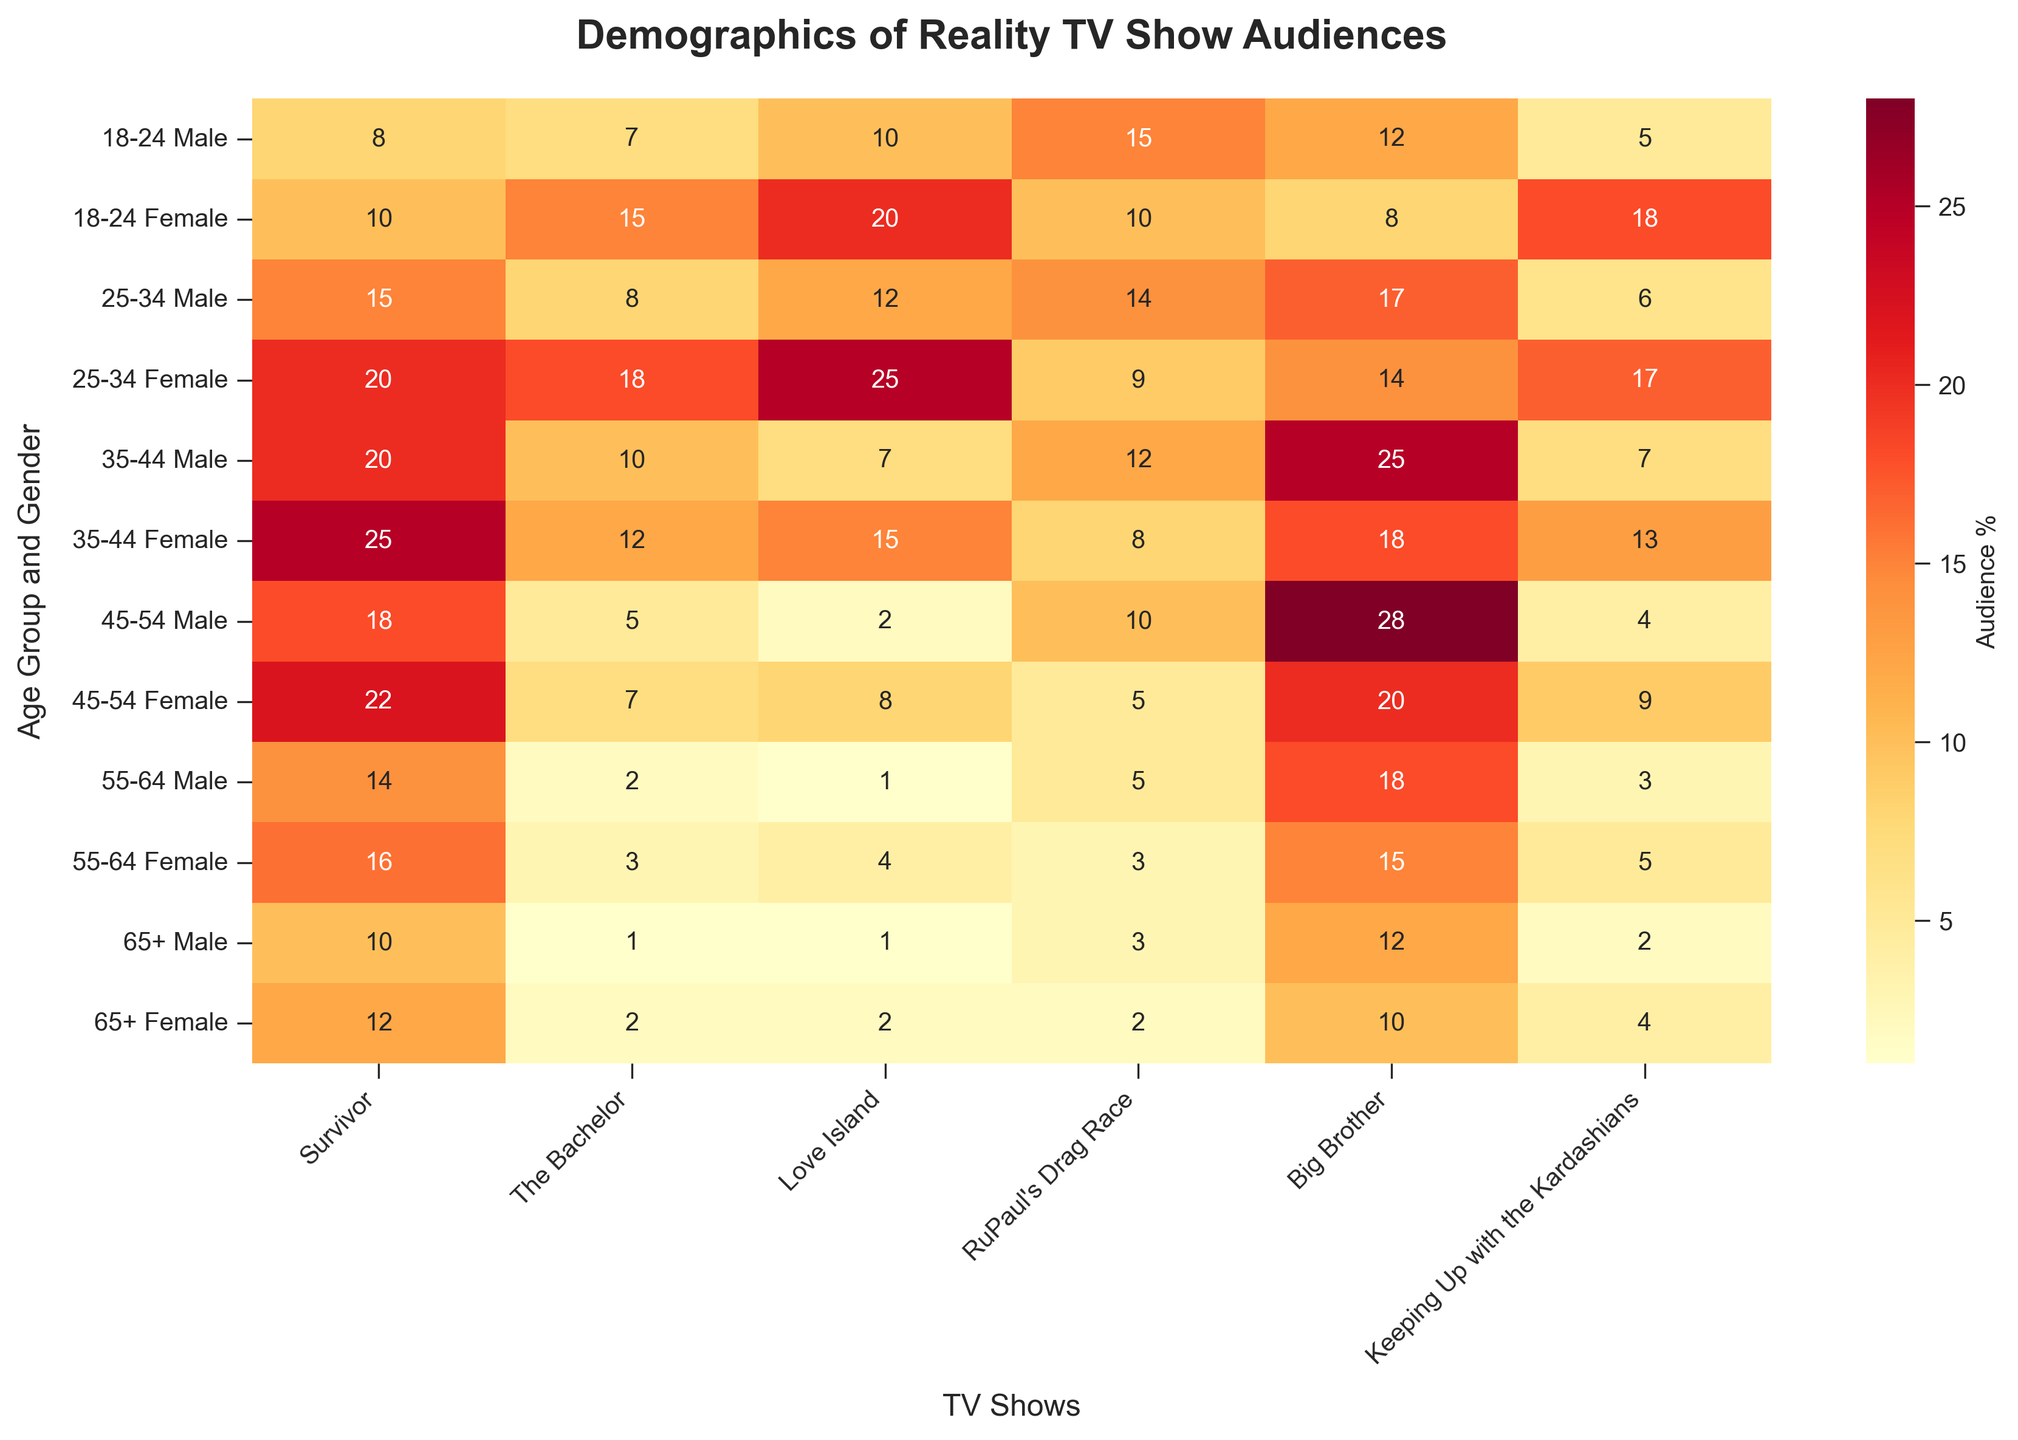What's the title of the heatmap? The title of the heatmap is displayed at the top of the figure in bold text. Reading the title tells us it's "Demographics of Reality TV Show Audiences."
Answer: Demographics of Reality TV Show Audiences Among the 18-24 age group, which show has the highest female viewership? For the 18-24 Female age group, we look at the row corresponding to "18-24 Female" and observe the highest value which is under "Love Island" with a value of 20.
Answer: Love Island Which age group and gender combination has the highest male viewership for "Big Brother"? To answer this, we examine the "Big Brother" column and identify the highest value for male age groups, which corresponds to the "45-54 Male" group with a value of 28.
Answer: 45-54 Male What's the combined viewership of "The Bachelor" for females in all age groups? Add the values of "The Bachelor" column for all female rows: 15 (18-24) + 18 (25-34) + 12 (35-44) + 7 (45-54) + 3 (55-64) + 2 (65+). 15+18+12+7+3+2=57.
Answer: 57 Which age group and gender combination has the least interest in "Love Island"? We find the lowest value in the "Love Island" column. The "65+ Male" and "55-64 Male" groups both have a value of 1 for this show, indicating the least interest.
Answer: 65+ Male, 55-64 Male Which show has the most balanced viewership between males and females aged 25-34? Calculate the difference in viewership between males and females for "25-34" age group for each show. The differences are 5 for Survivor, 10 for The Bachelor, 13 for Love Island, 5 for RuPaul’s Drag Race, 3 for Big Brother, and 11 for Keeping Up with the Kardashians. The smallest difference indicates the most balanced, which are "Survivor" and "RuPaul's Drag Race" with differences of 5.
Answer: Survivor, RuPaul’s Drag Race Between "Survivor" and "Keeping Up with the Kardashians," which show has higher viewership among the 35-44 Female demographic? Compare the values in the "35-44 Female" row for the two shows. "Survivor" has a value of 25 and "Keeping Up with the Kardashians" has a value of 13.
Answer: Survivor What is the average viewership of "RuPaul's Drag Race" across all age and gender groups? Add all the values in the "RuPaul's Drag Race" column, then divide by the number of groups (12): 15+10+14+9+12+8+10+5+5+3+3+2 = 96. 96/12 = 8.
Answer: 8 Which show do males aged 45-54 prefer the most? Observe the "45-54 Male" row to find the highest value, which is 28 for "Big Brother."
Answer: Big Brother 